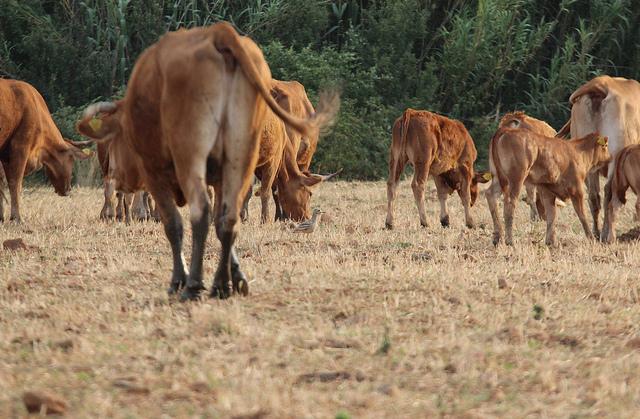What animals are this?
Quick response, please. Cows. What color is the grass?
Be succinct. Brown. Is this inside or outside?
Keep it brief. Outside. How many cows are there?
Be succinct. 9. 